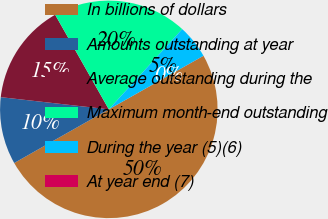<chart> <loc_0><loc_0><loc_500><loc_500><pie_chart><fcel>In billions of dollars<fcel>Amounts outstanding at year<fcel>Average outstanding during the<fcel>Maximum month-end outstanding<fcel>During the year (5)(6)<fcel>At year end (7)<nl><fcel>49.98%<fcel>10.0%<fcel>15.0%<fcel>20.0%<fcel>5.01%<fcel>0.01%<nl></chart> 